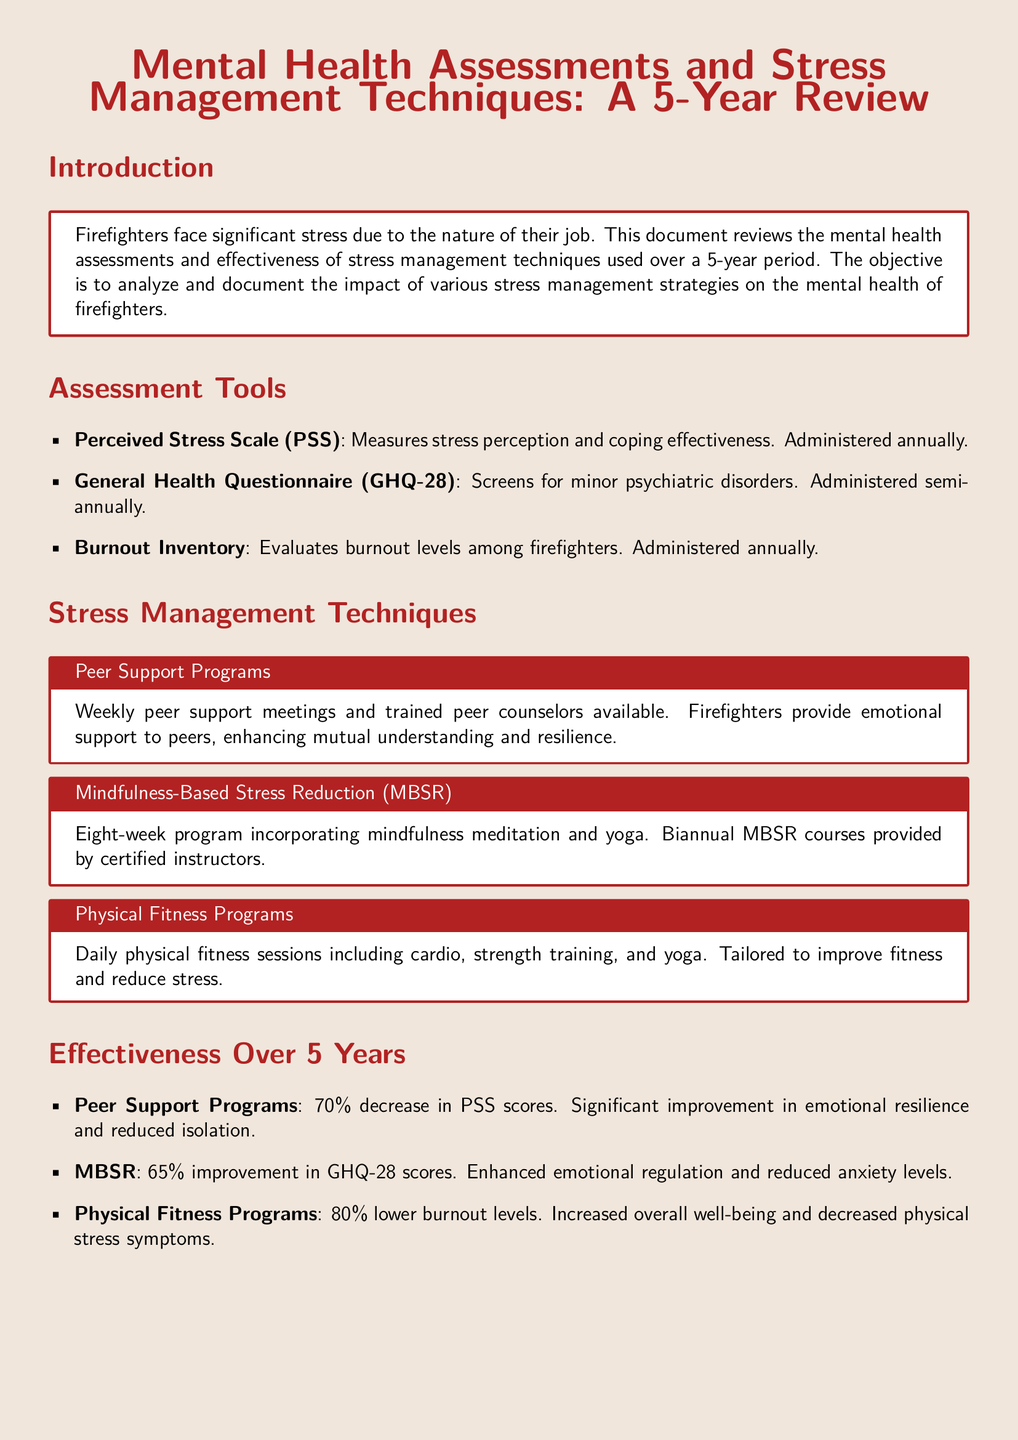What does PSS stand for? PSS is listed as one of the assessment tools in the document, and it stands for Perceived Stress Scale.
Answer: Perceived Stress Scale How often is the GHQ-28 administered? The document states that the General Health Questionnaire (GHQ-28) is administered semi-annually.
Answer: Semi-annually What percentage decrease in PSS scores was observed from Peer Support Programs? The effectiveness section mentions a 70% decrease in PSS scores due to Peer Support Programs.
Answer: 70% Which stress management technique had the highest impact on burnout levels? The effectiveness section indicates that the Physical Fitness Programs had an 80% lower burnout level compared to others.
Answer: Physical Fitness Programs How many weeks is the MBSR program? The stress management section notes that the Mindfulness-Based Stress Reduction program lasts eight weeks.
Answer: Eight weeks What is the primary goal of Peer Support Programs? The document explains that Peer Support Programs aim to provide emotional support to peers, enhancing mutual understanding.
Answer: Emotional support What improvement percentage in GHQ-28 scores was observed for MBSR? The effectiveness section shows a 65% improvement in GHQ-28 scores attributed to Mindfulness-Based Stress Reduction.
Answer: 65% Which stress management technique is provided biannually? The document states that the Mindfulness-Based Stress Reduction (MBSR) courses are provided biannually.
Answer: Mindfulness-Based Stress Reduction What was the overall outcome for firefighters' mental health strategies? The conclusion states that the combination of peer support, MBSR, and physical fitness programs effectively managed stress among firefighters.
Answer: Effectively managed stress 